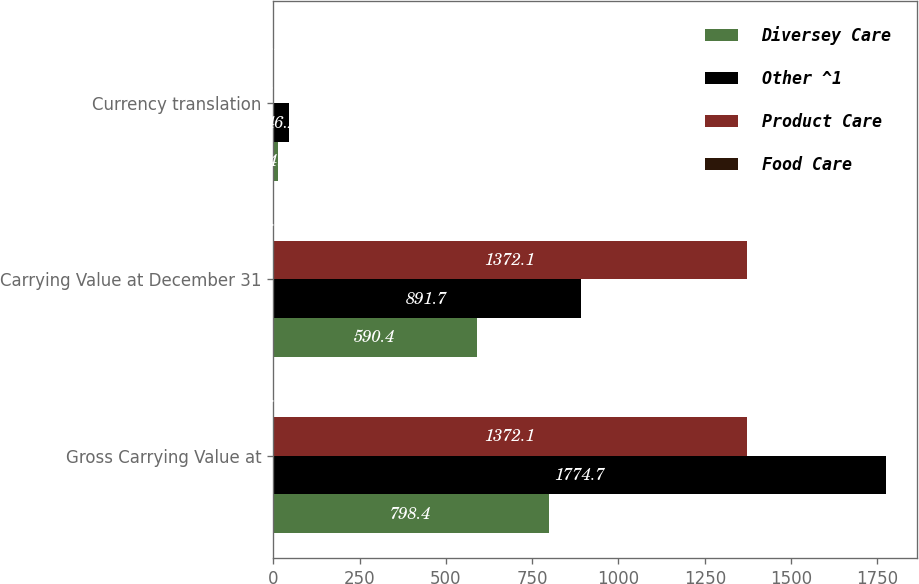Convert chart to OTSL. <chart><loc_0><loc_0><loc_500><loc_500><stacked_bar_chart><ecel><fcel>Gross Carrying Value at<fcel>Carrying Value at December 31<fcel>Currency translation<nl><fcel>Diversey Care<fcel>798.4<fcel>590.4<fcel>14.3<nl><fcel>Other ^1<fcel>1774.7<fcel>891.7<fcel>46.2<nl><fcel>Product Care<fcel>1372.1<fcel>1372.1<fcel>0.5<nl><fcel>Food Care<fcel>1.4<fcel>1.4<fcel>0.2<nl></chart> 